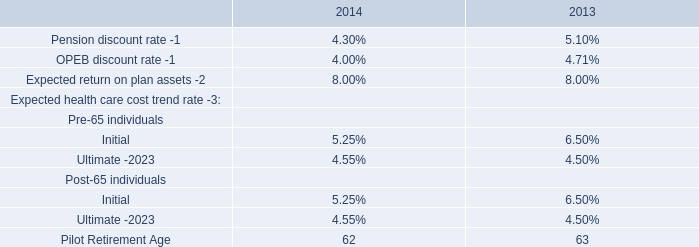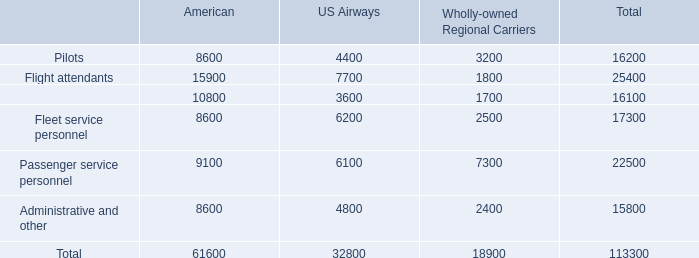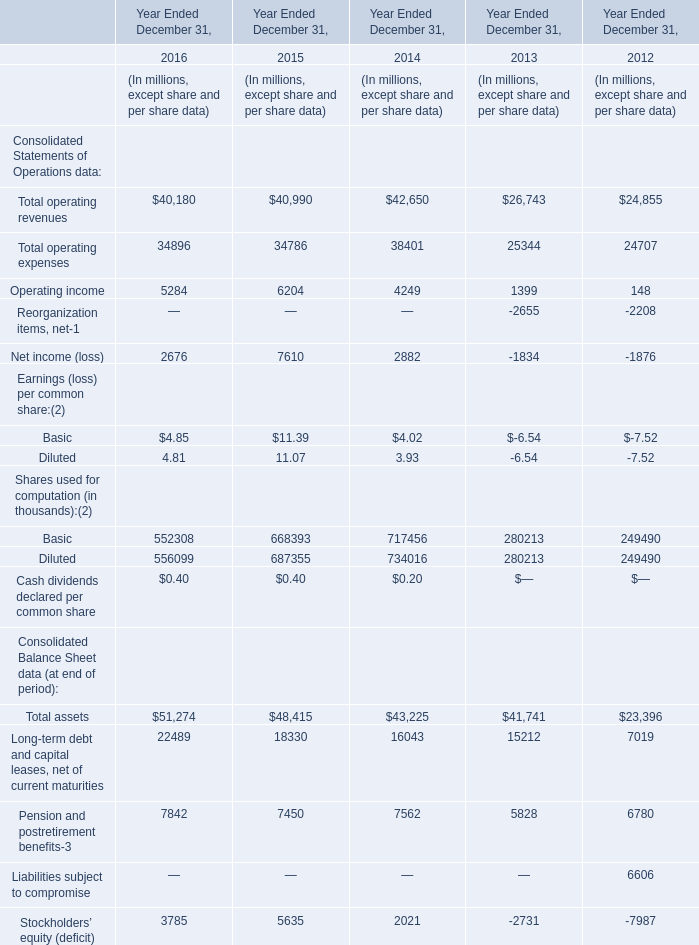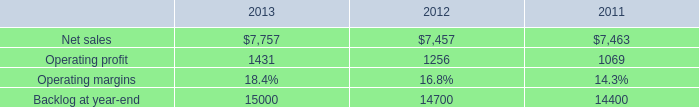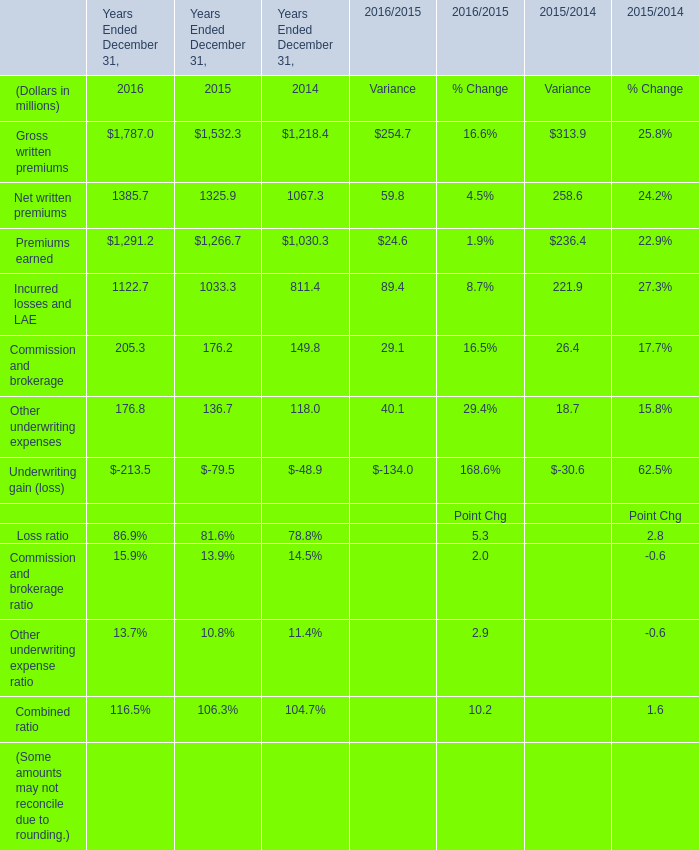What is the growing rate of Commission and brokerage in the year with the most Other underwriting expenses? (in %) 
Computations: ((205.3 - 176.2) / 176.2)
Answer: 0.16515. 